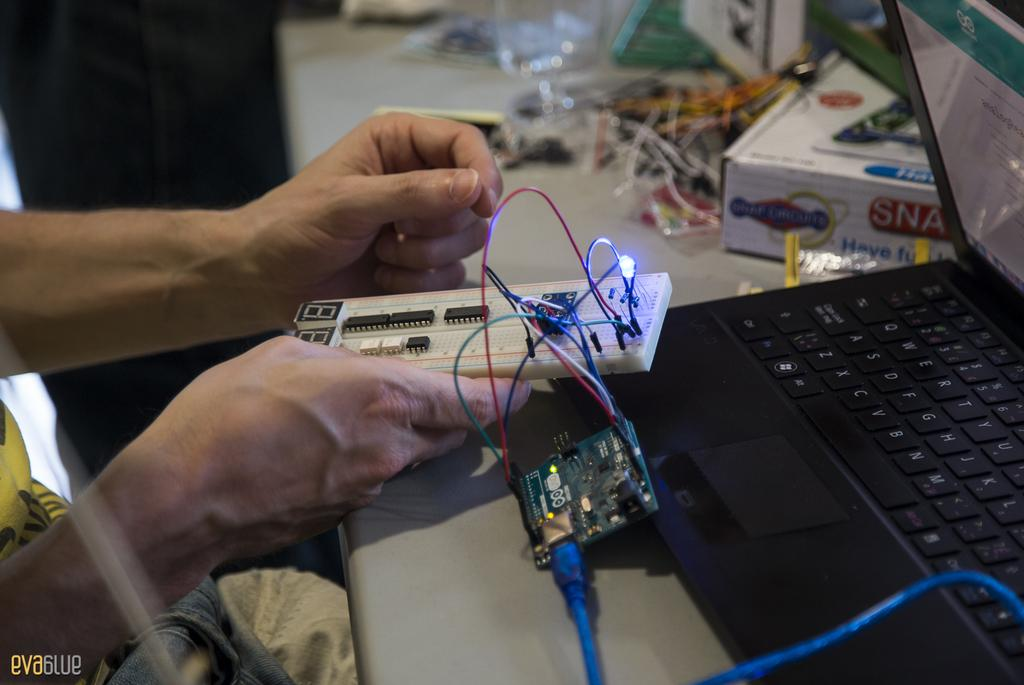What piece of furniture is present in the image? There is a table in the image. What electronic device is on the table? There is a laptop on the table. What other object is on the table? There is a box on the table. What is the hand in the image doing? The hand is holding a circuit board. What type of stocking is being used to hold the circuit board? There is no stocking present in the image; the hand is holding the circuit board. How does the button on the table help with the circuit board? There is no button present on the table or related to the circuit board in the image. 